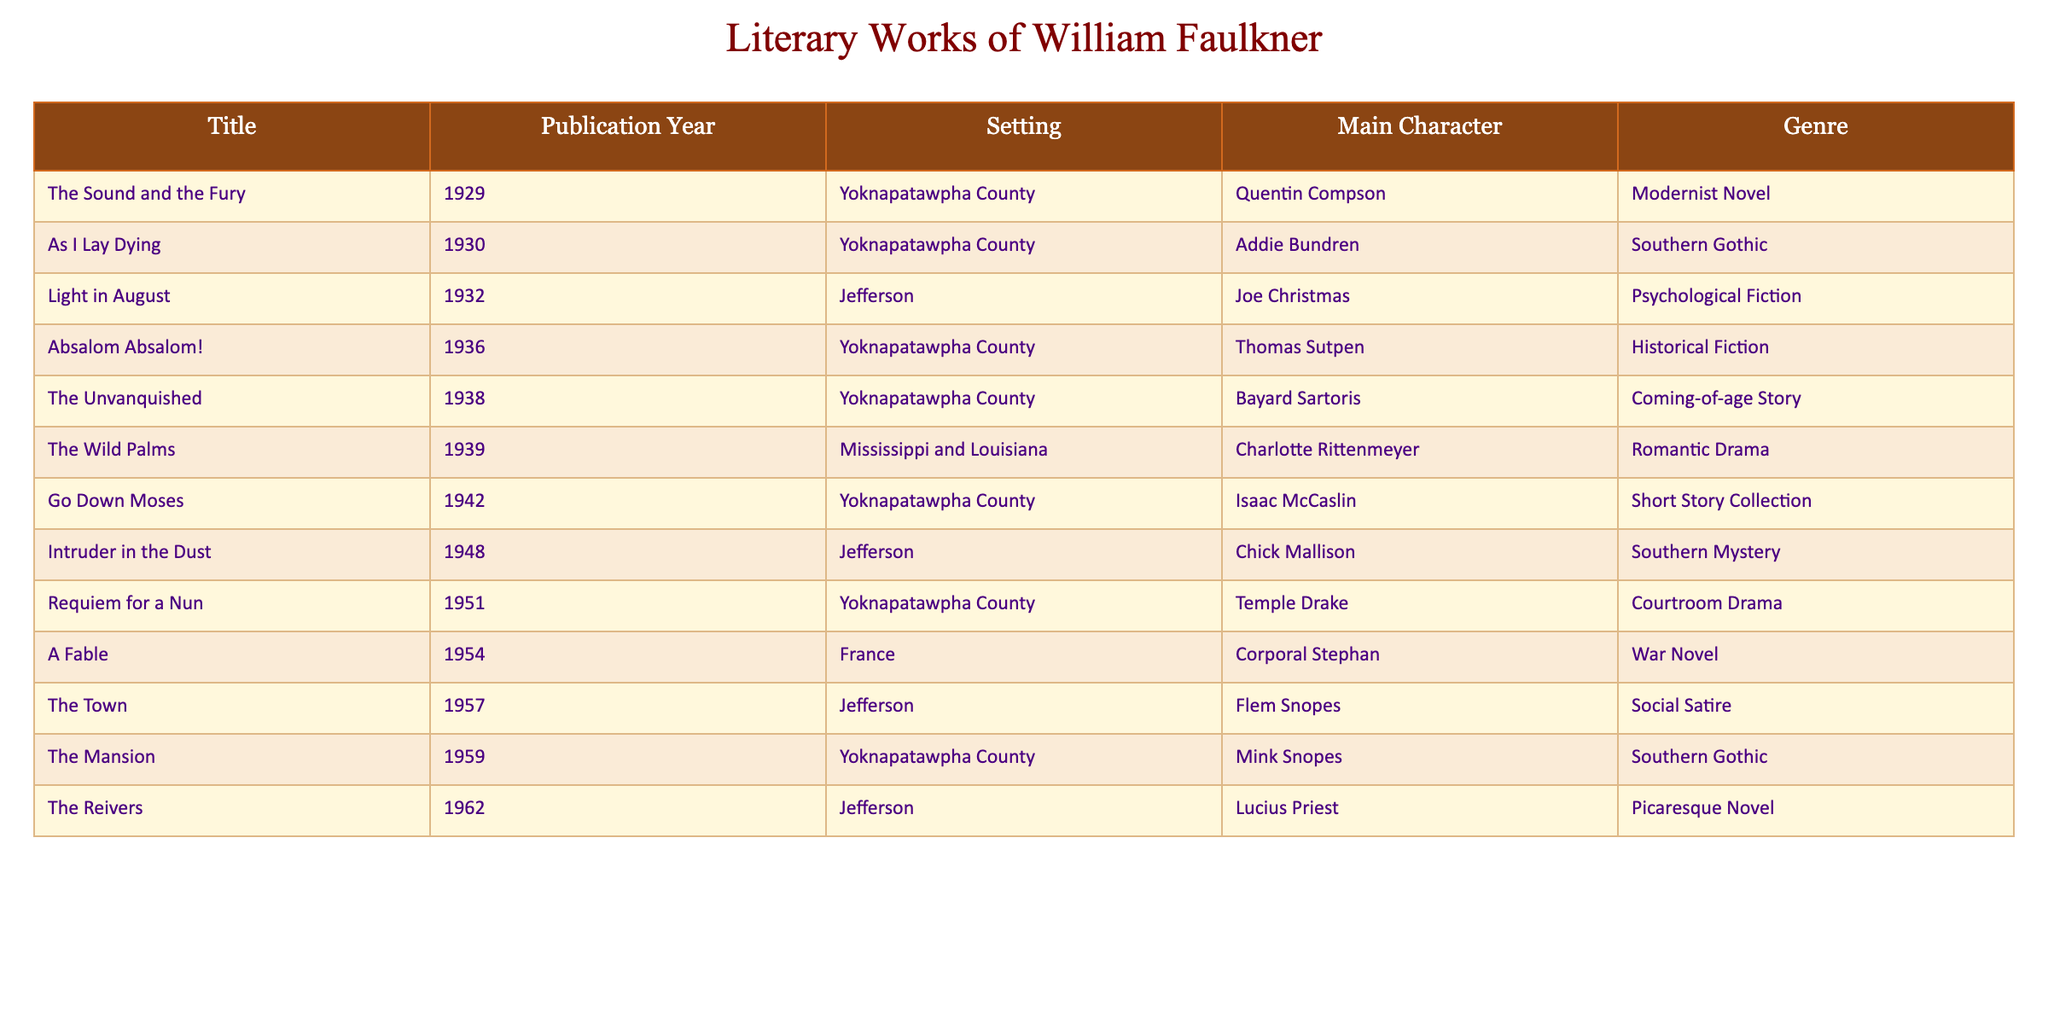What is the title of the work published in 1936? Referring to the table for the publication year 1936, the corresponding title is "Absalom Absalom!"
Answer: Absalom Absalom! Which literary work's main character is Joe Christmas? From the table, the main character Joe Christmas is found in "Light in August," which was published in 1932.
Answer: Light in August How many works are set in Yoknapatawpha County? Counting the entries in the table under the setting "Yoknapatawpha County," there are 6 works listed.
Answer: 6 Which genre is associated with "The Reivers"? Looking at the table, the genre listed for "The Reivers" is "Picaresque Novel."
Answer: Picaresque Novel Is "As I Lay Dying" considered a Southern Gothic work? Checking the table, "As I Lay Dying" is classified under the genre "Southern Gothic," so the answer is yes.
Answer: Yes What is the earliest published work in the table? The earliest publication year listed in the table is 1929, which corresponds to "The Sound and the Fury."
Answer: The Sound and the Fury How many years apart were the publications of "The Unvanquished" and "Go Down Moses"? "The Unvanquished" was published in 1938 and "Go Down Moses" in 1942, which are 4 years apart (1942 - 1938 = 4).
Answer: 4 years Are there any works that feature the character Mink Snopes? Yes, the table indicates that the character Mink Snopes appears in "The Mansion," published in 1959.
Answer: Yes Which work published in 1948 is set in Jefferson? Referring to the table, "Intruder in the Dust" is the work published in 1948 and set in Jefferson.
Answer: Intruder in the Dust What genre of literature encompasses the works published in 1930 and 1939? The 1930 work "As I Lay Dying" is Southern Gothic, while the 1939 work "The Wild Palms" is a Romantic Drama. This shows that these two genres are represented.
Answer: Southern Gothic and Romantic Drama What is the latest publication year in the table? The latest publication year listed is 1962, which corresponds to "The Reivers."
Answer: 1962 What are the titles of all works published in the 1930s? Reviewing the table for works published in the 1930s, we find "As I Lay Dying" (1930), "Light in August" (1932), "Absalom Absalom!" (1936), "The Unvanquished" (1938), and "The Wild Palms" (1939).
Answer: As I Lay Dying, Light in August, Absalom Absalom!, The Unvanquished, The Wild Palms In terms of literary genres, which are present in the works listed? The table shows several genres, which include Modernist Novel, Southern Gothic, Psychological Fiction, Historical Fiction, Coming-of-age Story, Romantic Drama, Short Story Collection, Southern Mystery, Courtroom Drama, War Novel, Social Satire, Picaresque Novel. These represent a diverse range of genres in Faulkner's works.
Answer: Modernist Novel, Southern Gothic, Psychological Fiction, Historical Fiction, Coming-of-age Story, Romantic Drama, Short Story Collection, Southern Mystery, Courtroom Drama, War Novel, Social Satire, Picaresque Novel 